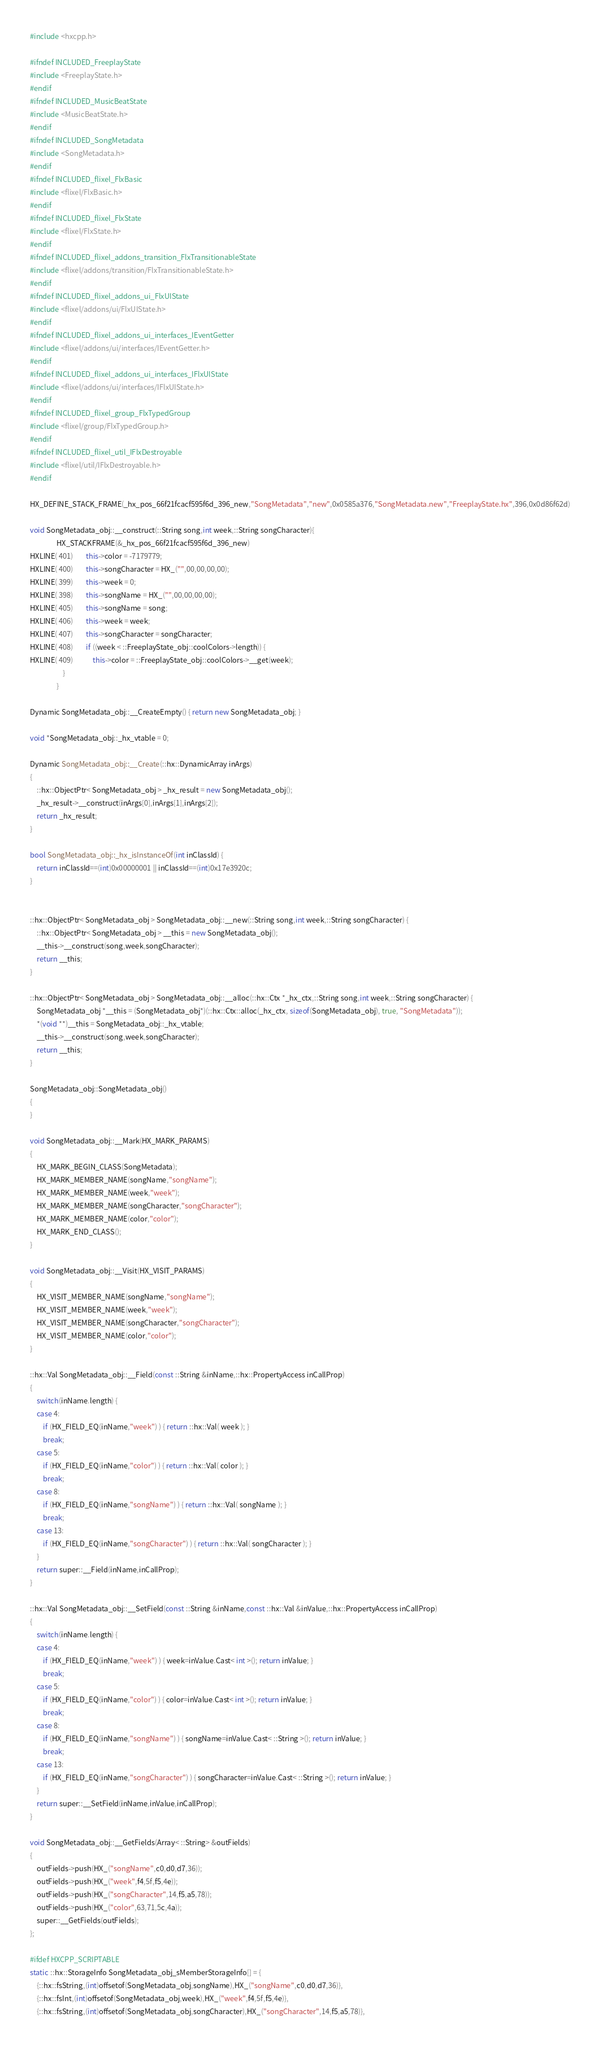<code> <loc_0><loc_0><loc_500><loc_500><_C++_>#include <hxcpp.h>

#ifndef INCLUDED_FreeplayState
#include <FreeplayState.h>
#endif
#ifndef INCLUDED_MusicBeatState
#include <MusicBeatState.h>
#endif
#ifndef INCLUDED_SongMetadata
#include <SongMetadata.h>
#endif
#ifndef INCLUDED_flixel_FlxBasic
#include <flixel/FlxBasic.h>
#endif
#ifndef INCLUDED_flixel_FlxState
#include <flixel/FlxState.h>
#endif
#ifndef INCLUDED_flixel_addons_transition_FlxTransitionableState
#include <flixel/addons/transition/FlxTransitionableState.h>
#endif
#ifndef INCLUDED_flixel_addons_ui_FlxUIState
#include <flixel/addons/ui/FlxUIState.h>
#endif
#ifndef INCLUDED_flixel_addons_ui_interfaces_IEventGetter
#include <flixel/addons/ui/interfaces/IEventGetter.h>
#endif
#ifndef INCLUDED_flixel_addons_ui_interfaces_IFlxUIState
#include <flixel/addons/ui/interfaces/IFlxUIState.h>
#endif
#ifndef INCLUDED_flixel_group_FlxTypedGroup
#include <flixel/group/FlxTypedGroup.h>
#endif
#ifndef INCLUDED_flixel_util_IFlxDestroyable
#include <flixel/util/IFlxDestroyable.h>
#endif

HX_DEFINE_STACK_FRAME(_hx_pos_66f21fcacf595f6d_396_new,"SongMetadata","new",0x0585a376,"SongMetadata.new","FreeplayState.hx",396,0x0d86f62d)

void SongMetadata_obj::__construct(::String song,int week,::String songCharacter){
            	HX_STACKFRAME(&_hx_pos_66f21fcacf595f6d_396_new)
HXLINE( 401)		this->color = -7179779;
HXLINE( 400)		this->songCharacter = HX_("",00,00,00,00);
HXLINE( 399)		this->week = 0;
HXLINE( 398)		this->songName = HX_("",00,00,00,00);
HXLINE( 405)		this->songName = song;
HXLINE( 406)		this->week = week;
HXLINE( 407)		this->songCharacter = songCharacter;
HXLINE( 408)		if ((week < ::FreeplayState_obj::coolColors->length)) {
HXLINE( 409)			this->color = ::FreeplayState_obj::coolColors->__get(week);
            		}
            	}

Dynamic SongMetadata_obj::__CreateEmpty() { return new SongMetadata_obj; }

void *SongMetadata_obj::_hx_vtable = 0;

Dynamic SongMetadata_obj::__Create(::hx::DynamicArray inArgs)
{
	::hx::ObjectPtr< SongMetadata_obj > _hx_result = new SongMetadata_obj();
	_hx_result->__construct(inArgs[0],inArgs[1],inArgs[2]);
	return _hx_result;
}

bool SongMetadata_obj::_hx_isInstanceOf(int inClassId) {
	return inClassId==(int)0x00000001 || inClassId==(int)0x17e3920c;
}


::hx::ObjectPtr< SongMetadata_obj > SongMetadata_obj::__new(::String song,int week,::String songCharacter) {
	::hx::ObjectPtr< SongMetadata_obj > __this = new SongMetadata_obj();
	__this->__construct(song,week,songCharacter);
	return __this;
}

::hx::ObjectPtr< SongMetadata_obj > SongMetadata_obj::__alloc(::hx::Ctx *_hx_ctx,::String song,int week,::String songCharacter) {
	SongMetadata_obj *__this = (SongMetadata_obj*)(::hx::Ctx::alloc(_hx_ctx, sizeof(SongMetadata_obj), true, "SongMetadata"));
	*(void **)__this = SongMetadata_obj::_hx_vtable;
	__this->__construct(song,week,songCharacter);
	return __this;
}

SongMetadata_obj::SongMetadata_obj()
{
}

void SongMetadata_obj::__Mark(HX_MARK_PARAMS)
{
	HX_MARK_BEGIN_CLASS(SongMetadata);
	HX_MARK_MEMBER_NAME(songName,"songName");
	HX_MARK_MEMBER_NAME(week,"week");
	HX_MARK_MEMBER_NAME(songCharacter,"songCharacter");
	HX_MARK_MEMBER_NAME(color,"color");
	HX_MARK_END_CLASS();
}

void SongMetadata_obj::__Visit(HX_VISIT_PARAMS)
{
	HX_VISIT_MEMBER_NAME(songName,"songName");
	HX_VISIT_MEMBER_NAME(week,"week");
	HX_VISIT_MEMBER_NAME(songCharacter,"songCharacter");
	HX_VISIT_MEMBER_NAME(color,"color");
}

::hx::Val SongMetadata_obj::__Field(const ::String &inName,::hx::PropertyAccess inCallProp)
{
	switch(inName.length) {
	case 4:
		if (HX_FIELD_EQ(inName,"week") ) { return ::hx::Val( week ); }
		break;
	case 5:
		if (HX_FIELD_EQ(inName,"color") ) { return ::hx::Val( color ); }
		break;
	case 8:
		if (HX_FIELD_EQ(inName,"songName") ) { return ::hx::Val( songName ); }
		break;
	case 13:
		if (HX_FIELD_EQ(inName,"songCharacter") ) { return ::hx::Val( songCharacter ); }
	}
	return super::__Field(inName,inCallProp);
}

::hx::Val SongMetadata_obj::__SetField(const ::String &inName,const ::hx::Val &inValue,::hx::PropertyAccess inCallProp)
{
	switch(inName.length) {
	case 4:
		if (HX_FIELD_EQ(inName,"week") ) { week=inValue.Cast< int >(); return inValue; }
		break;
	case 5:
		if (HX_FIELD_EQ(inName,"color") ) { color=inValue.Cast< int >(); return inValue; }
		break;
	case 8:
		if (HX_FIELD_EQ(inName,"songName") ) { songName=inValue.Cast< ::String >(); return inValue; }
		break;
	case 13:
		if (HX_FIELD_EQ(inName,"songCharacter") ) { songCharacter=inValue.Cast< ::String >(); return inValue; }
	}
	return super::__SetField(inName,inValue,inCallProp);
}

void SongMetadata_obj::__GetFields(Array< ::String> &outFields)
{
	outFields->push(HX_("songName",c0,d0,d7,36));
	outFields->push(HX_("week",f4,5f,f5,4e));
	outFields->push(HX_("songCharacter",14,f5,a5,78));
	outFields->push(HX_("color",63,71,5c,4a));
	super::__GetFields(outFields);
};

#ifdef HXCPP_SCRIPTABLE
static ::hx::StorageInfo SongMetadata_obj_sMemberStorageInfo[] = {
	{::hx::fsString,(int)offsetof(SongMetadata_obj,songName),HX_("songName",c0,d0,d7,36)},
	{::hx::fsInt,(int)offsetof(SongMetadata_obj,week),HX_("week",f4,5f,f5,4e)},
	{::hx::fsString,(int)offsetof(SongMetadata_obj,songCharacter),HX_("songCharacter",14,f5,a5,78)},</code> 